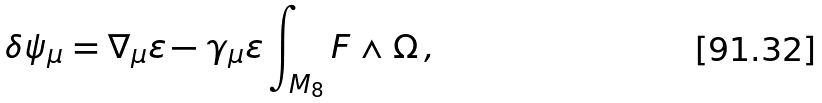Convert formula to latex. <formula><loc_0><loc_0><loc_500><loc_500>\delta \psi _ { \mu } = \nabla _ { \mu } \varepsilon - \gamma _ { \mu } \varepsilon \int _ { M _ { 8 } } F \wedge \Omega \, ,</formula> 